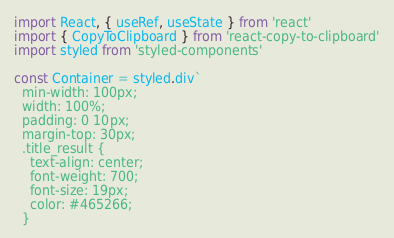Convert code to text. <code><loc_0><loc_0><loc_500><loc_500><_JavaScript_>import React, { useRef, useState } from 'react'
import { CopyToClipboard } from 'react-copy-to-clipboard'
import styled from 'styled-components'

const Container = styled.div`
  min-width: 100px;
  width: 100%;
  padding: 0 10px;
  margin-top: 30px;
  .title_result {
    text-align: center;
    font-weight: 700;
    font-size: 19px;
    color: #465266;
  }</code> 